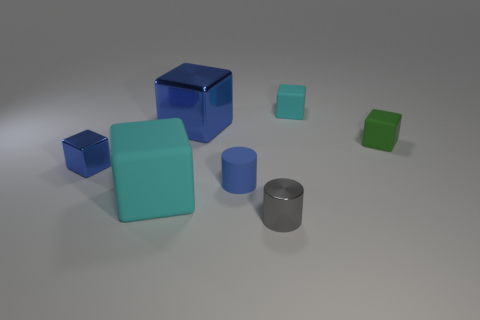What material is the cube that is the same color as the big metallic object?
Make the answer very short. Metal. Do the blue object on the right side of the big blue shiny cube and the small cyan thing have the same material?
Ensure brevity in your answer.  Yes. Is the number of small blue things in front of the big cyan object the same as the number of tiny rubber blocks left of the small green block?
Your response must be concise. No. Is there anything else that is the same size as the shiny cylinder?
Give a very brief answer. Yes. There is a blue thing that is the same shape as the gray metallic object; what material is it?
Your answer should be very brief. Rubber. There is a block in front of the blue matte cylinder that is on the right side of the large shiny thing; are there any big matte cubes that are behind it?
Ensure brevity in your answer.  No. There is a cyan matte object that is behind the green matte cube; is its shape the same as the small blue object that is on the right side of the large cyan matte block?
Your answer should be very brief. No. Is the number of big blue metal cubes that are to the right of the big metal block greater than the number of large blue metal cubes?
Your answer should be very brief. No. How many objects are either brown objects or blue cubes?
Your answer should be compact. 2. What color is the big shiny cube?
Your answer should be very brief. Blue. 